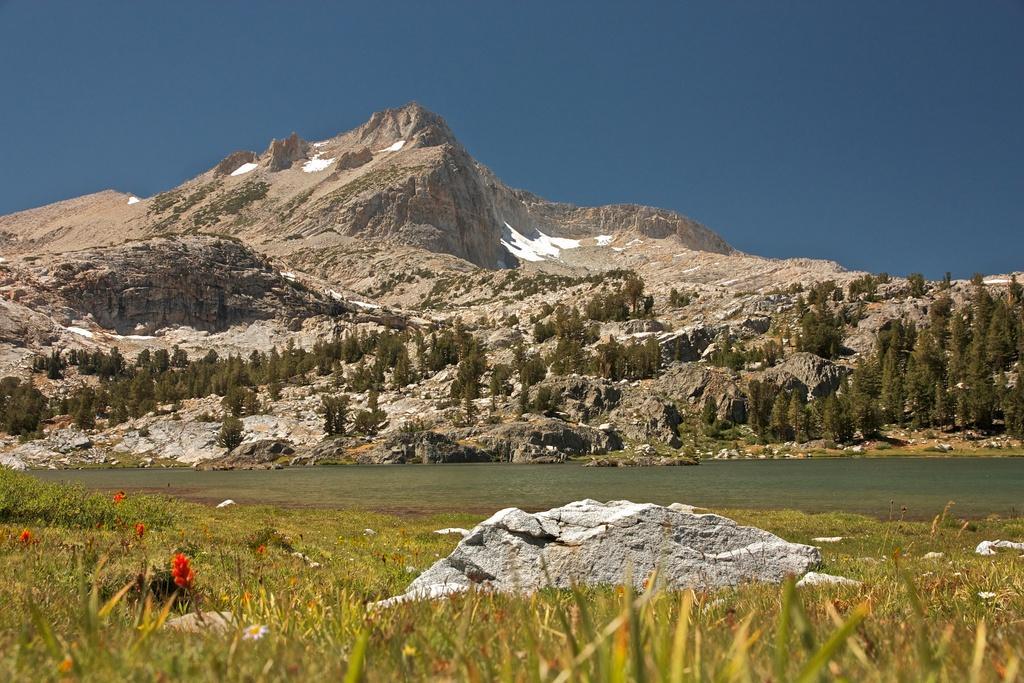Can you describe this image briefly? There are flowers, greenery and stone at the bottom side of the image, it seems to be there is water in the center and there are trees, mountains and sky in the background area. 